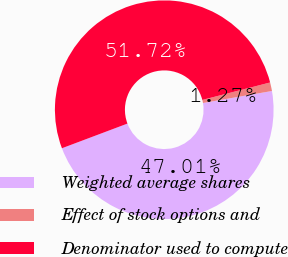Convert chart. <chart><loc_0><loc_0><loc_500><loc_500><pie_chart><fcel>Weighted average shares<fcel>Effect of stock options and<fcel>Denominator used to compute<nl><fcel>47.01%<fcel>1.27%<fcel>51.72%<nl></chart> 